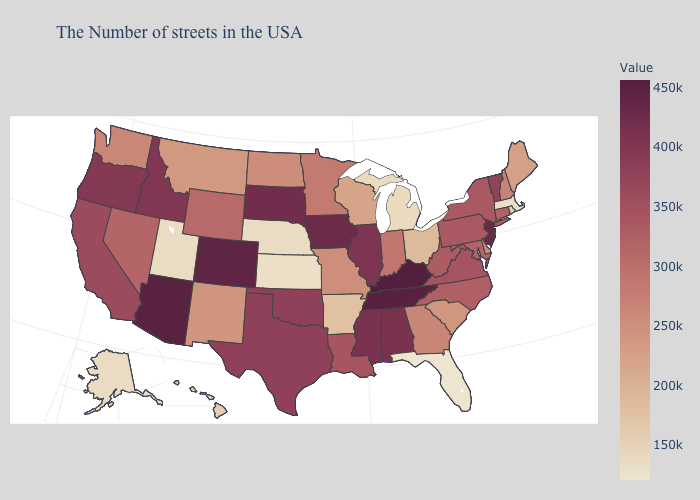Among the states that border Massachusetts , does Connecticut have the highest value?
Give a very brief answer. No. Which states have the lowest value in the USA?
Be succinct. Florida. Which states have the lowest value in the Northeast?
Concise answer only. Massachusetts. Among the states that border Nevada , which have the lowest value?
Keep it brief. Utah. Does the map have missing data?
Concise answer only. No. Does North Dakota have the highest value in the MidWest?
Quick response, please. No. Does Wisconsin have a higher value than Rhode Island?
Concise answer only. Yes. Does Hawaii have a higher value than Colorado?
Short answer required. No. Which states have the lowest value in the Northeast?
Be succinct. Massachusetts. 